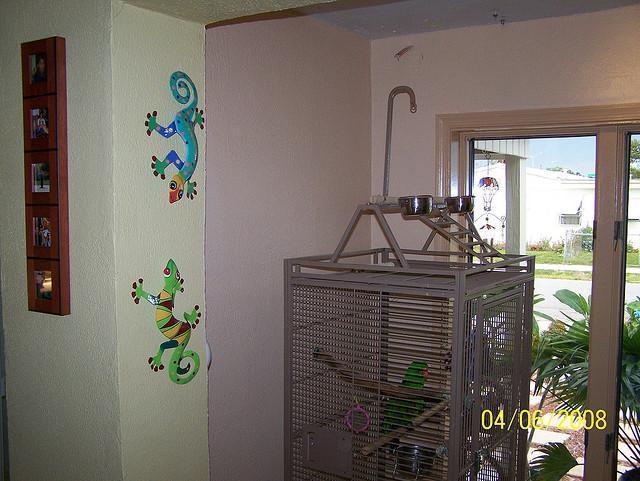How many potted plants are there?
Give a very brief answer. 1. 